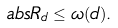<formula> <loc_0><loc_0><loc_500><loc_500>\ a b s { R _ { d } } \leq \omega ( d ) .</formula> 